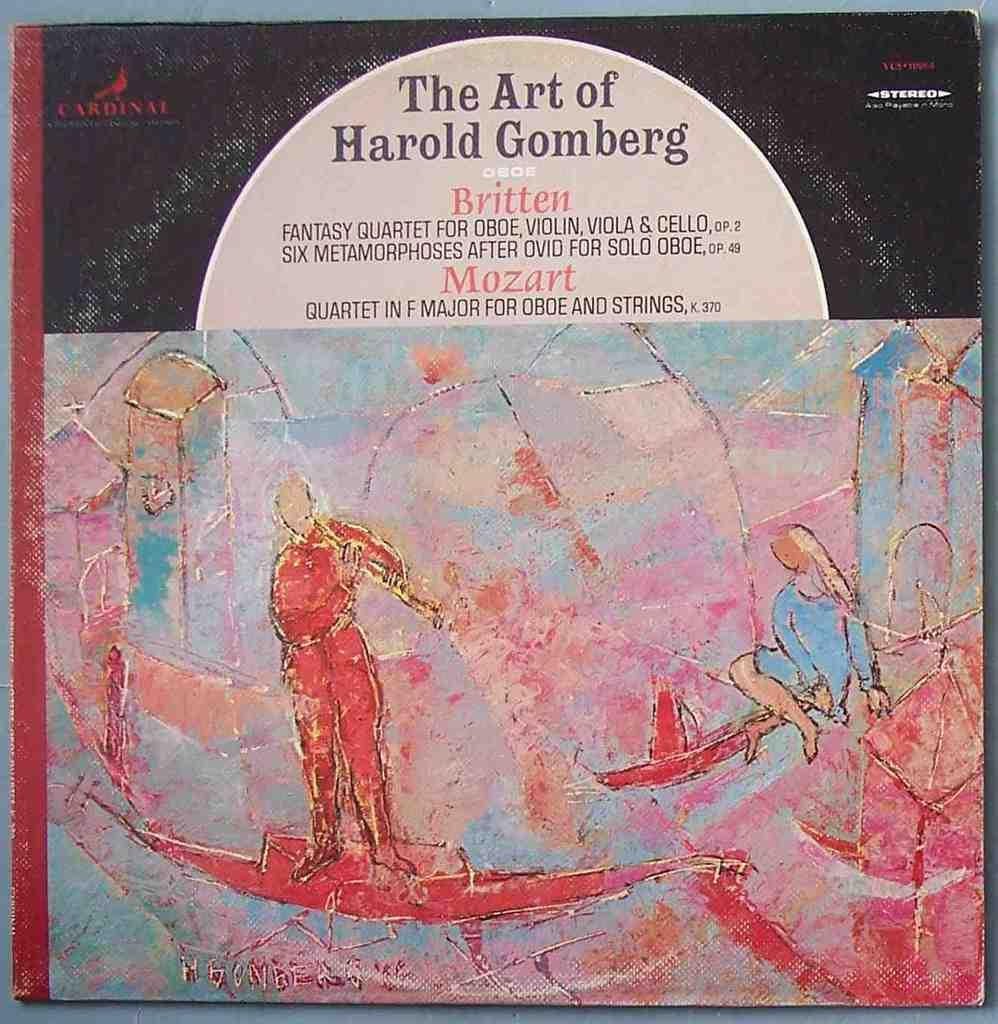<image>
Relay a brief, clear account of the picture shown. An album in pnk, blue and gold is for The Art of Harold Gomberg. 